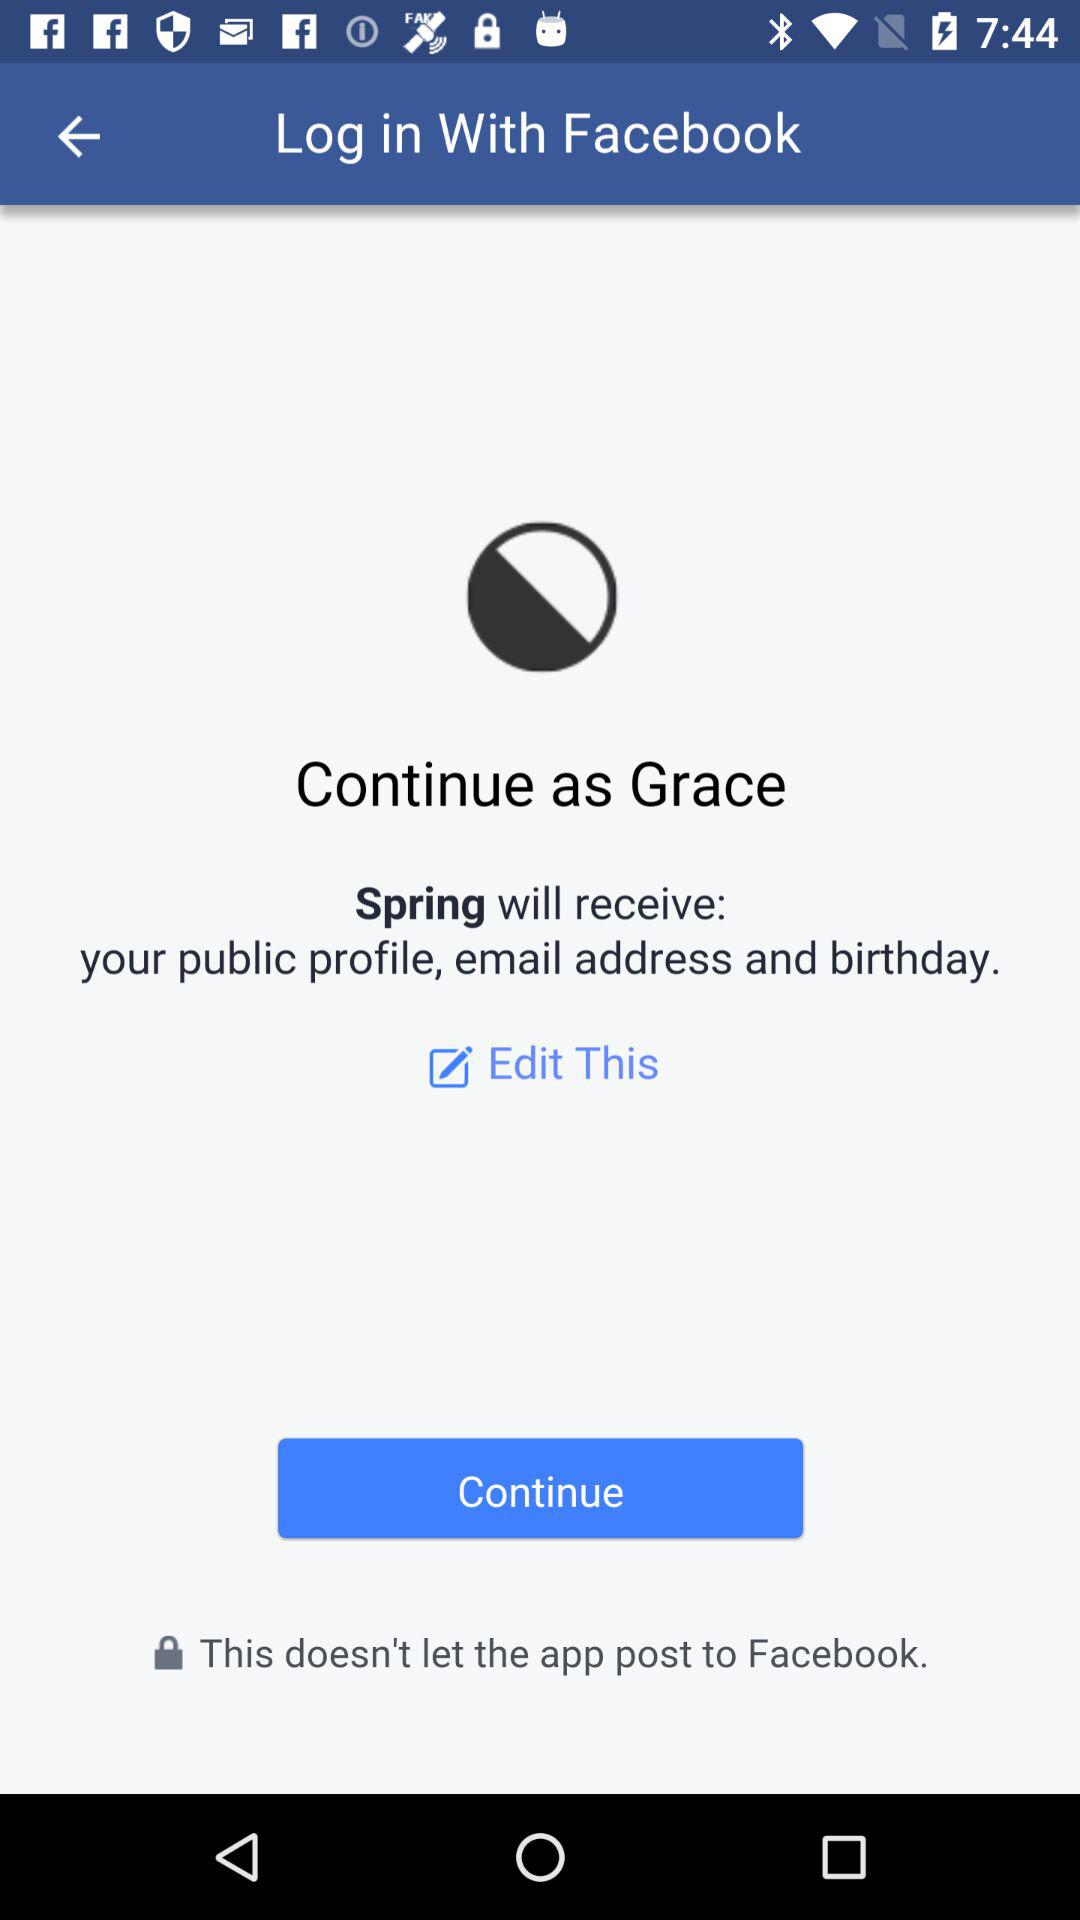Which information will "Spring" receive? "Spring" will receive your public profile, email address and birthday. 